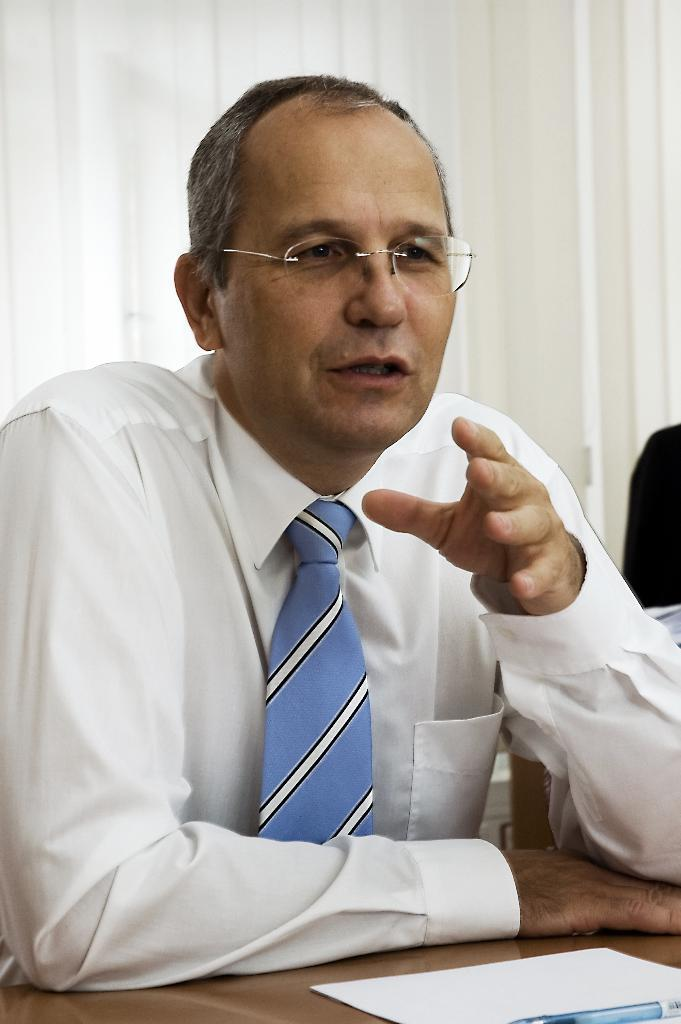What is the person in the image doing? There is a person sitting on a chair in the image. What is on the table in the image? There is a paper and a pen on the table in the image. What type of expert can be seen laughing in the image? There is no expert or laughter present in the image; it only shows a person sitting on a chair and items on a table. 